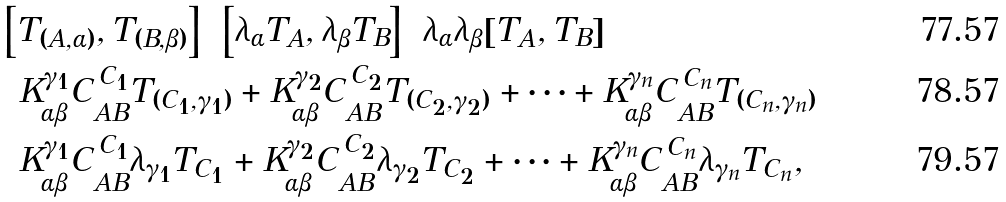Convert formula to latex. <formula><loc_0><loc_0><loc_500><loc_500>& \left [ T _ { ( A , \alpha ) } , T _ { ( B , \beta ) } \right ] = \left [ \lambda _ { \alpha } T _ { A } , \lambda _ { \beta } T _ { B } \right ] = \lambda _ { \alpha } \lambda _ { \beta } [ T _ { A } , T _ { B } ] = \\ & = K _ { \alpha \beta } ^ { \gamma _ { 1 } } C _ { A B } ^ { \, C _ { 1 } } T _ { ( C _ { 1 } , \gamma _ { 1 } ) } + K _ { \alpha \beta } ^ { \gamma _ { 2 } } C _ { A B } ^ { \, C _ { 2 } } T _ { ( C _ { 2 } , \gamma _ { 2 } ) } + \cdots + K _ { \alpha \beta } ^ { \gamma _ { n } } C _ { A B } ^ { \, C _ { n } } T _ { ( C _ { n } , \gamma _ { n } ) } = \\ & = K _ { \alpha \beta } ^ { \gamma _ { 1 } } C _ { A B } ^ { \, C _ { 1 } } \lambda _ { \gamma _ { 1 } } T _ { C _ { 1 } } + K _ { \alpha \beta } ^ { \gamma _ { 2 } } C _ { A B } ^ { \, C _ { 2 } } \lambda _ { \gamma _ { 2 } } T _ { C _ { 2 } } + \cdots + K _ { \alpha \beta } ^ { \gamma _ { n } } C _ { A B } ^ { \, C _ { n } } \lambda _ { \gamma _ { n } } T _ { C _ { n } } ,</formula> 